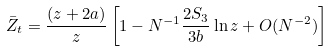<formula> <loc_0><loc_0><loc_500><loc_500>\bar { Z } _ { t } = \frac { ( z + 2 a ) } { z } \left [ 1 - N ^ { - 1 } \frac { 2 S _ { 3 } } { 3 b } \ln z + O ( N ^ { - 2 } ) \right ]</formula> 